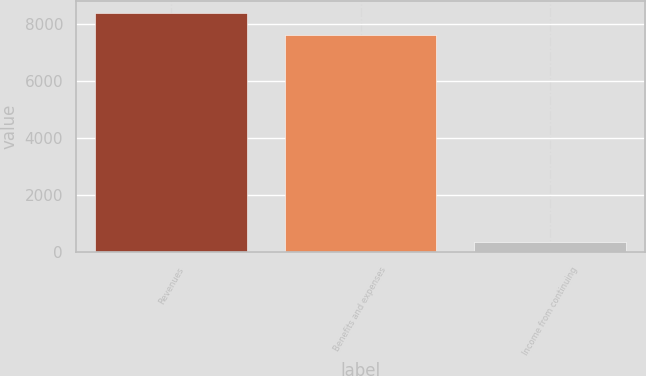Convert chart to OTSL. <chart><loc_0><loc_0><loc_500><loc_500><bar_chart><fcel>Revenues<fcel>Benefits and expenses<fcel>Income from continuing<nl><fcel>8373.2<fcel>7612<fcel>370<nl></chart> 